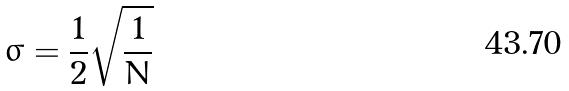Convert formula to latex. <formula><loc_0><loc_0><loc_500><loc_500>\sigma = \frac { 1 } { 2 } \sqrt { \frac { 1 } { N } }</formula> 